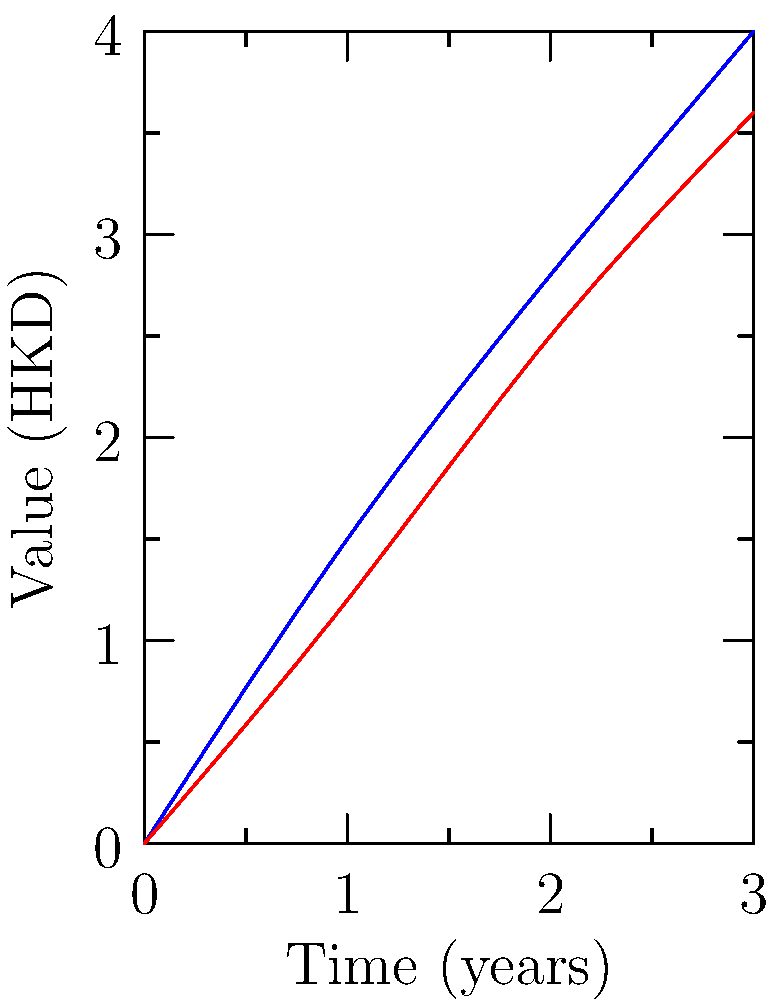A Hong Kong investor is considering two financial assets, A and B, represented by the blue and red curves respectively in the graph. If the initial investment for each asset is 1,000,000 HKD, calculate the difference in the return on investment (ROI) between Asset A and Asset B after 3 years, expressed as a percentage. To solve this problem, we'll follow these steps:

1. Determine the final values of Assets A and B after 3 years:
   Asset A: 4,000,000 HKD
   Asset B: 3,600,000 HKD

2. Calculate the ROI for each asset:
   ROI = (Final Value - Initial Value) / Initial Value * 100%

   For Asset A:
   $ROI_A = \frac{4,000,000 - 1,000,000}{1,000,000} \times 100\% = 300\%$

   For Asset B:
   $ROI_B = \frac{3,600,000 - 1,000,000}{1,000,000} \times 100\% = 260\%$

3. Calculate the difference in ROI:
   $ROI_{difference} = ROI_A - ROI_B = 300\% - 260\% = 40\%$

Therefore, the difference in ROI between Asset A and Asset B after 3 years is 40 percentage points.
Answer: 40% 